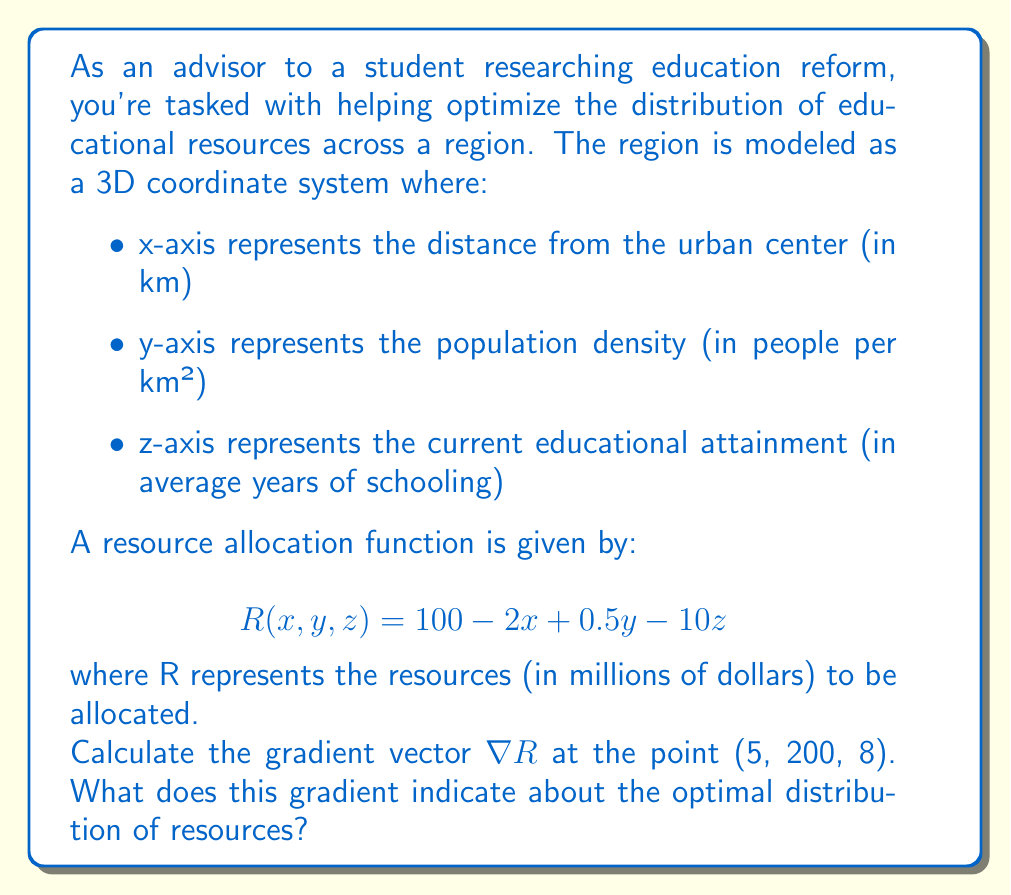Could you help me with this problem? To solve this problem, we need to follow these steps:

1) The gradient vector $\nabla R$ is defined as:

   $$\nabla R = \left(\frac{\partial R}{\partial x}, \frac{\partial R}{\partial y}, \frac{\partial R}{\partial z}\right)$$

2) We need to calculate the partial derivatives:

   $\frac{\partial R}{\partial x} = -2$
   $\frac{\partial R}{\partial y} = 0.5$
   $\frac{\partial R}{\partial z} = -10$

3) Therefore, the gradient vector is:

   $$\nabla R = (-2, 0.5, -10)$$

4) This gradient is constant and doesn't depend on the point, but we can interpret it at the given point (5, 200, 8).

5) The gradient vector indicates the direction of steepest increase in the function R. In this case:

   - The negative x-component (-2) indicates that resources decrease as we move away from the urban center.
   - The positive y-component (0.5) indicates that resources increase with higher population density.
   - The negative z-component (-10) indicates that resources decrease in areas with higher current educational attainment.

6) The magnitude of each component indicates the rate of change in that direction. The z-component has the largest magnitude, suggesting that current educational attainment has the strongest influence on resource allocation.

This gradient suggests that for optimal distribution, more resources should be allocated to areas closer to the urban center, with higher population density, and lower current educational attainment.
Answer: $\nabla R = (-2, 0.5, -10)$

This gradient indicates that for optimal resource distribution, more resources should be allocated to areas closer to the urban center (x decreases), with higher population density (y increases), and lower current educational attainment (z decreases), with current educational attainment having the strongest influence on the allocation. 